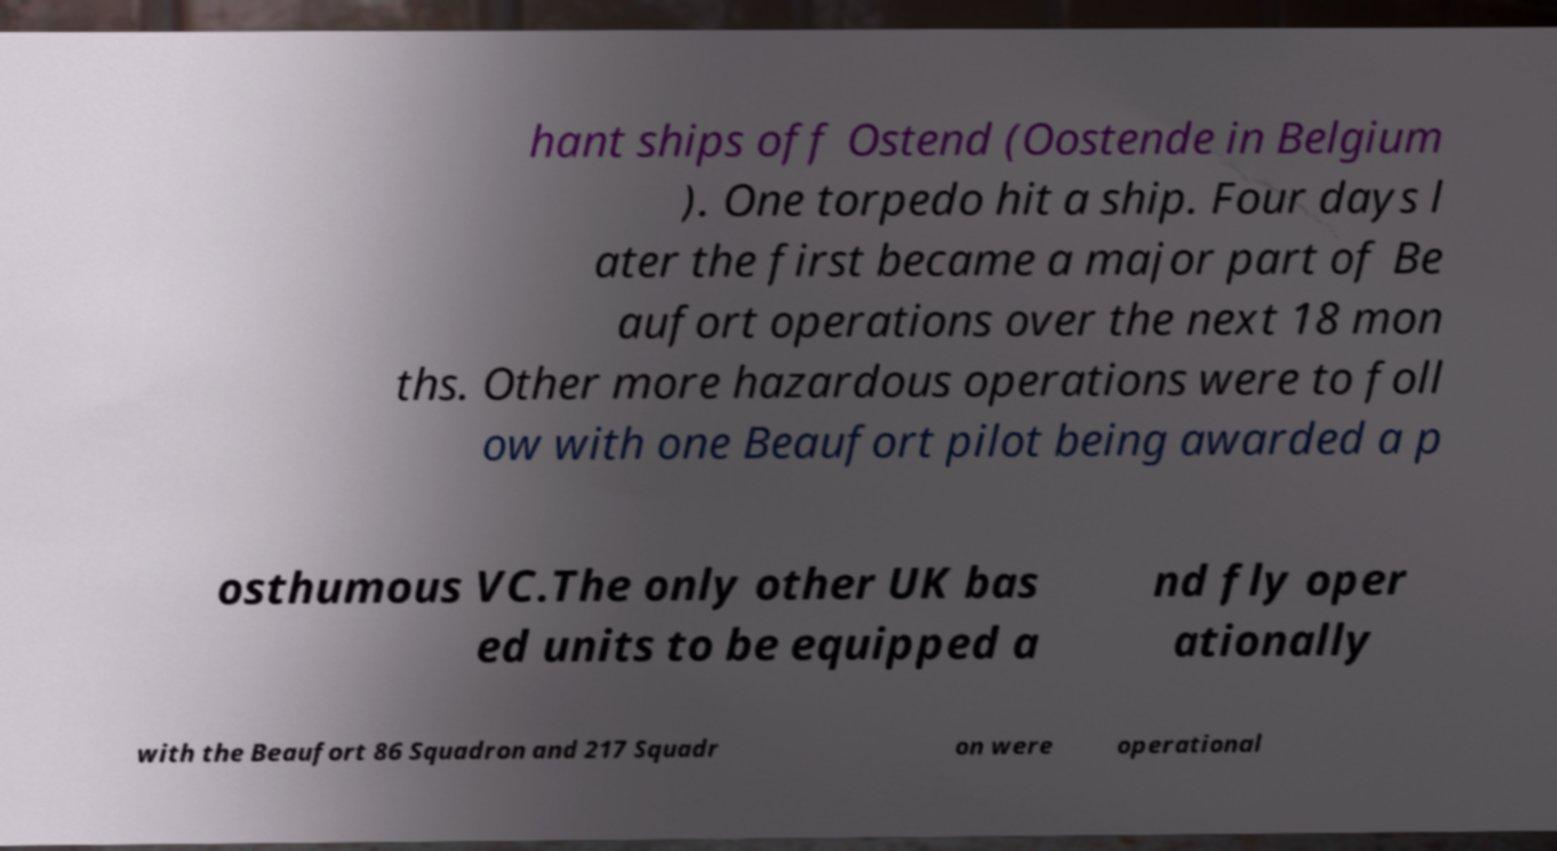Can you accurately transcribe the text from the provided image for me? hant ships off Ostend (Oostende in Belgium ). One torpedo hit a ship. Four days l ater the first became a major part of Be aufort operations over the next 18 mon ths. Other more hazardous operations were to foll ow with one Beaufort pilot being awarded a p osthumous VC.The only other UK bas ed units to be equipped a nd fly oper ationally with the Beaufort 86 Squadron and 217 Squadr on were operational 